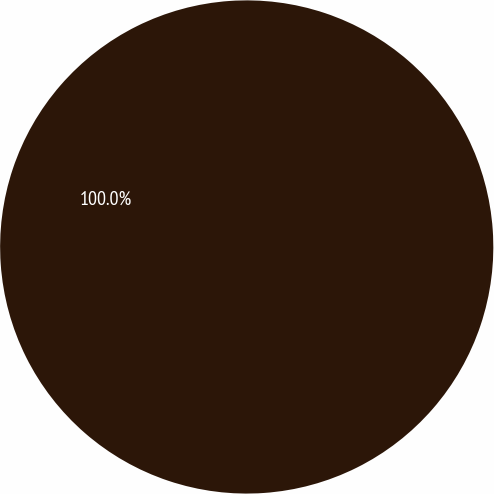Convert chart to OTSL. <chart><loc_0><loc_0><loc_500><loc_500><pie_chart><ecel><nl><fcel>100.0%<nl></chart> 